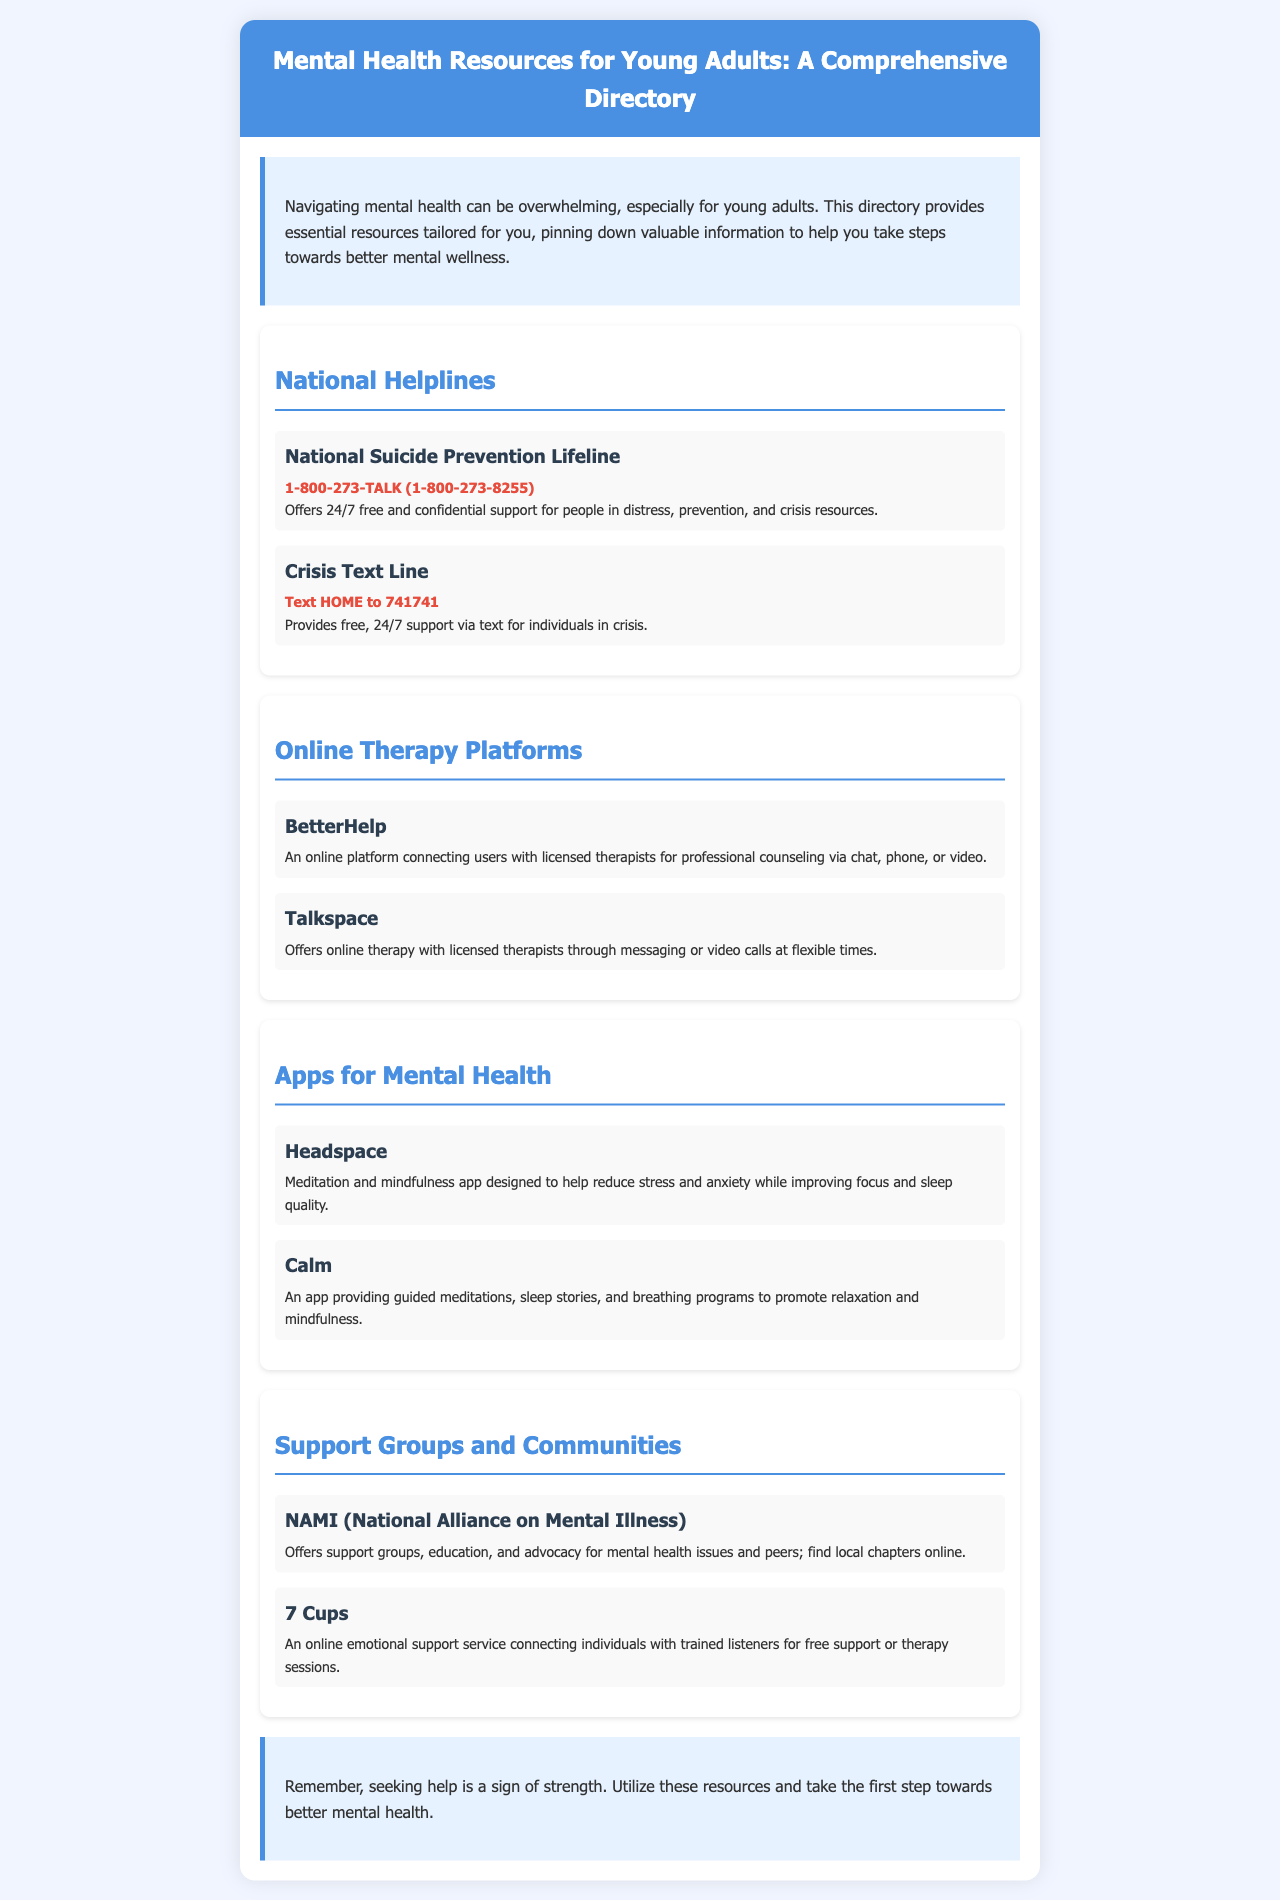what is the contact number for the National Suicide Prevention Lifeline? The document provides the number for the National Suicide Prevention Lifeline as 1-800-273-TALK (1-800-273-8255).
Answer: 1-800-273-TALK (1-800-273-8255) what is the main purpose of the Crisis Text Line? The document mentions that the Crisis Text Line provides free, 24/7 support via text for individuals in crisis.
Answer: Support via text for individuals in crisis how many online therapy platforms are listed in the document? The document lists two online therapy platforms: BetterHelp and Talkspace.
Answer: Two which app is designed to help reduce stress and anxiety? The document states that Headspace is designed to help reduce stress and anxiety while improving focus and sleep quality.
Answer: Headspace what organization offers support groups for mental health issues? The document states that NAMI (National Alliance on Mental Illness) offers support groups for mental health issues and peers.
Answer: NAMI (National Alliance on Mental Illness) which section contains resources for meditation? The section titled "Apps for Mental Health" contains resources for meditation, specifically mentioning Headspace and Calm.
Answer: Apps for Mental Health what is stated about seeking help in the conclusion? The conclusion emphasizes that seeking help is a sign of strength, encouraging individuals to utilize the resources.
Answer: Seeking help is a sign of strength what type of resources does 7 Cups provide? The document indicates that 7 Cups connects individuals with trained listeners for free support or therapy sessions.
Answer: Free support or therapy sessions 